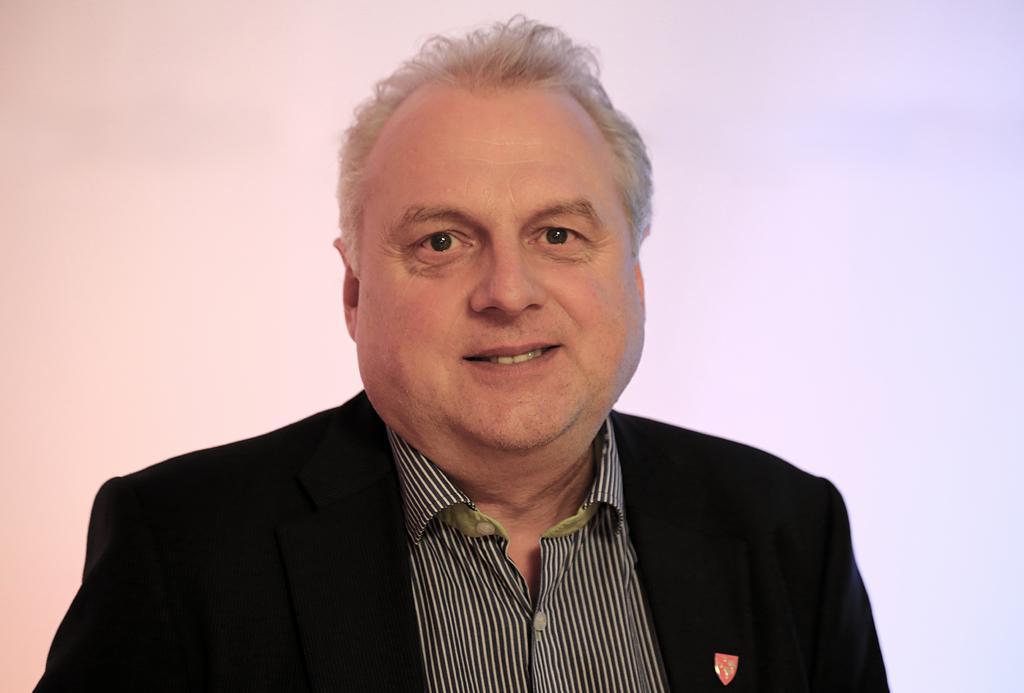Could you give a brief overview of what you see in this image? In this image I can see a person wearing black and white shirt and black colored blazer. I can see the blue and pink colored background. 